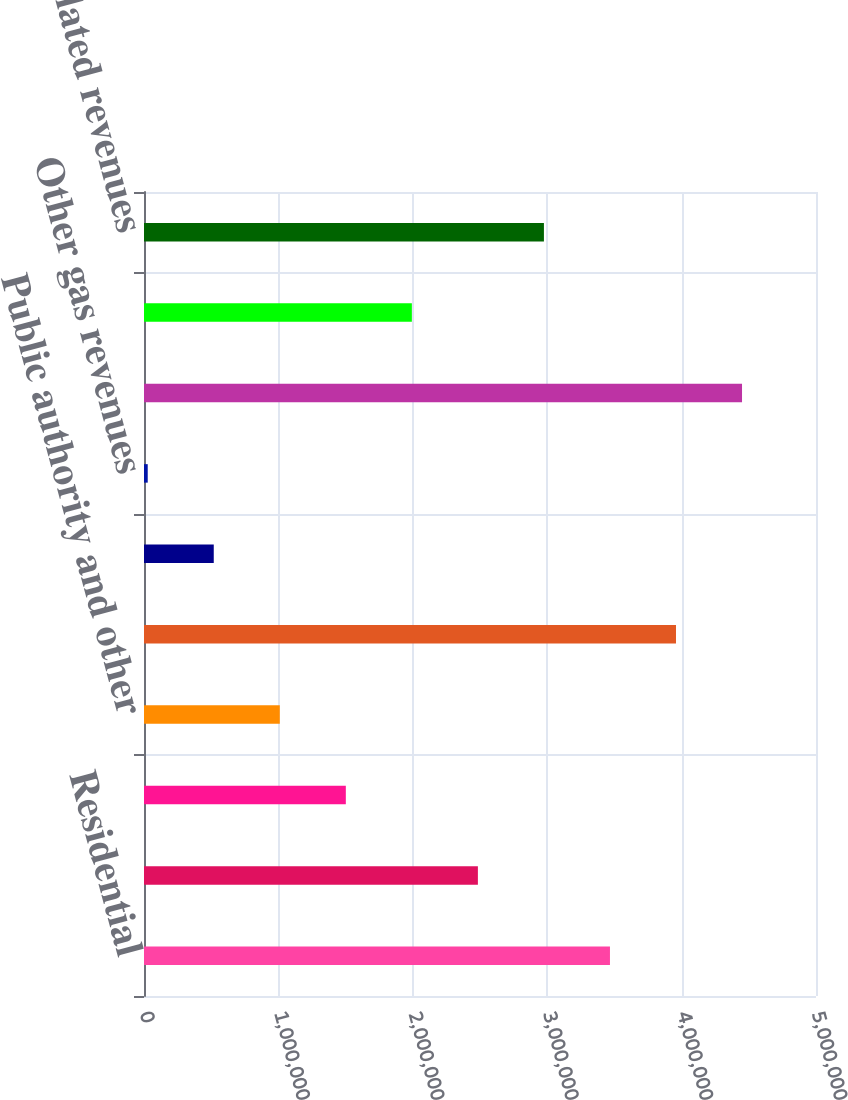Convert chart. <chart><loc_0><loc_0><loc_500><loc_500><bar_chart><fcel>Residential<fcel>Commercial<fcel>Industrial<fcel>Public authority and other<fcel>Total gas sales revenues<fcel>Transportation revenues<fcel>Other gas revenues<fcel>Total regulated distribution<fcel>Regulated pipeline revenues<fcel>Nonregulated revenues<nl><fcel>3.46695e+06<fcel>2.48431e+06<fcel>1.50167e+06<fcel>1.01035e+06<fcel>3.95827e+06<fcel>519028<fcel>27707<fcel>4.4496e+06<fcel>1.99299e+06<fcel>2.97563e+06<nl></chart> 